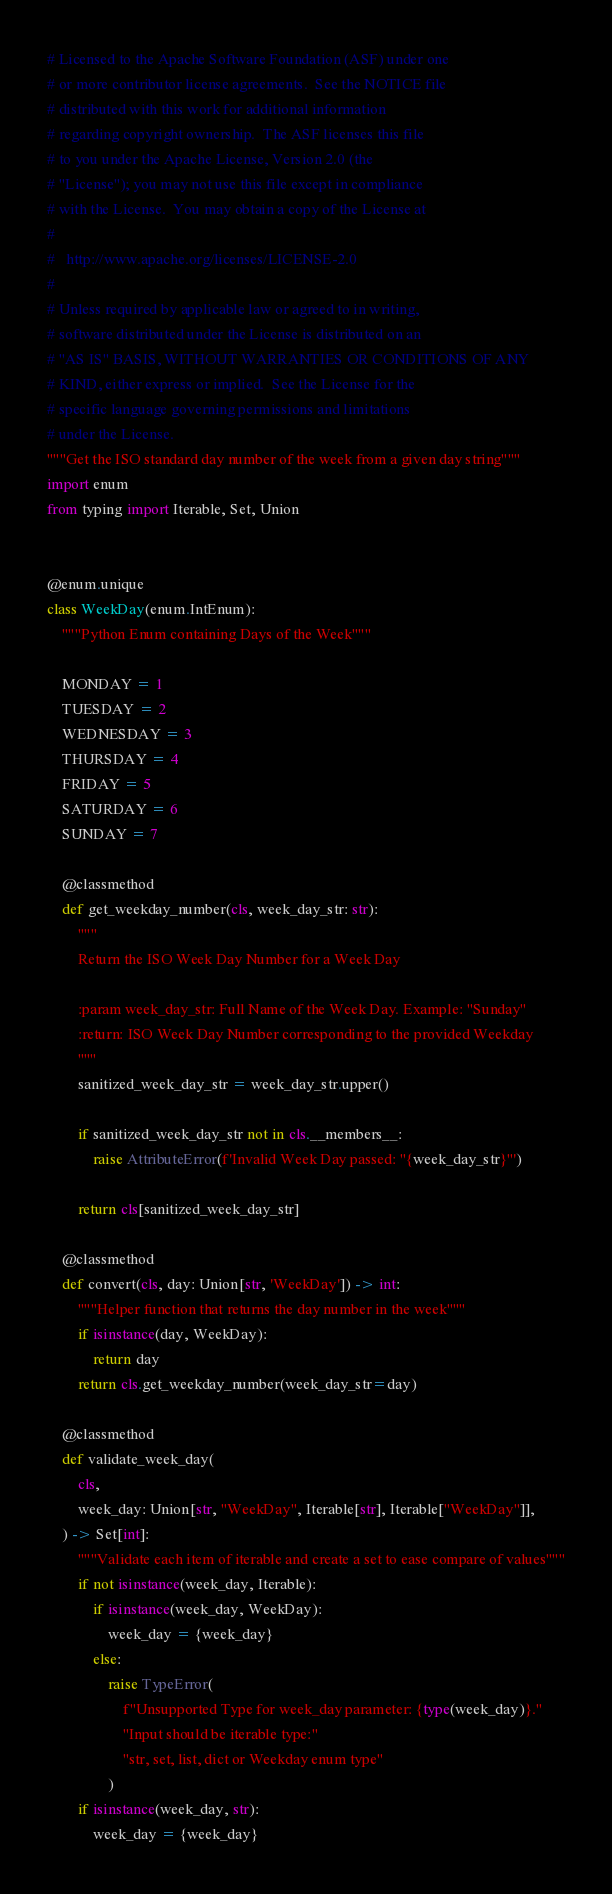<code> <loc_0><loc_0><loc_500><loc_500><_Python_># Licensed to the Apache Software Foundation (ASF) under one
# or more contributor license agreements.  See the NOTICE file
# distributed with this work for additional information
# regarding copyright ownership.  The ASF licenses this file
# to you under the Apache License, Version 2.0 (the
# "License"); you may not use this file except in compliance
# with the License.  You may obtain a copy of the License at
#
#   http://www.apache.org/licenses/LICENSE-2.0
#
# Unless required by applicable law or agreed to in writing,
# software distributed under the License is distributed on an
# "AS IS" BASIS, WITHOUT WARRANTIES OR CONDITIONS OF ANY
# KIND, either express or implied.  See the License for the
# specific language governing permissions and limitations
# under the License.
"""Get the ISO standard day number of the week from a given day string"""
import enum
from typing import Iterable, Set, Union


@enum.unique
class WeekDay(enum.IntEnum):
    """Python Enum containing Days of the Week"""

    MONDAY = 1
    TUESDAY = 2
    WEDNESDAY = 3
    THURSDAY = 4
    FRIDAY = 5
    SATURDAY = 6
    SUNDAY = 7

    @classmethod
    def get_weekday_number(cls, week_day_str: str):
        """
        Return the ISO Week Day Number for a Week Day

        :param week_day_str: Full Name of the Week Day. Example: "Sunday"
        :return: ISO Week Day Number corresponding to the provided Weekday
        """
        sanitized_week_day_str = week_day_str.upper()

        if sanitized_week_day_str not in cls.__members__:
            raise AttributeError(f'Invalid Week Day passed: "{week_day_str}"')

        return cls[sanitized_week_day_str]

    @classmethod
    def convert(cls, day: Union[str, 'WeekDay']) -> int:
        """Helper function that returns the day number in the week"""
        if isinstance(day, WeekDay):
            return day
        return cls.get_weekday_number(week_day_str=day)

    @classmethod
    def validate_week_day(
        cls,
        week_day: Union[str, "WeekDay", Iterable[str], Iterable["WeekDay"]],
    ) -> Set[int]:
        """Validate each item of iterable and create a set to ease compare of values"""
        if not isinstance(week_day, Iterable):
            if isinstance(week_day, WeekDay):
                week_day = {week_day}
            else:
                raise TypeError(
                    f"Unsupported Type for week_day parameter: {type(week_day)}."
                    "Input should be iterable type:"
                    "str, set, list, dict or Weekday enum type"
                )
        if isinstance(week_day, str):
            week_day = {week_day}
</code> 